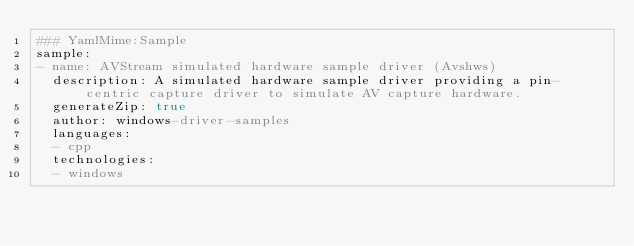<code> <loc_0><loc_0><loc_500><loc_500><_YAML_>### YamlMime:Sample
sample:
- name: AVStream simulated hardware sample driver (Avshws)
  description: A simulated hardware sample driver providing a pin-centric capture driver to simulate AV capture hardware.
  generateZip: true
  author: windows-driver-samples
  languages:
  - cpp
  technologies:
  - windows
</code> 